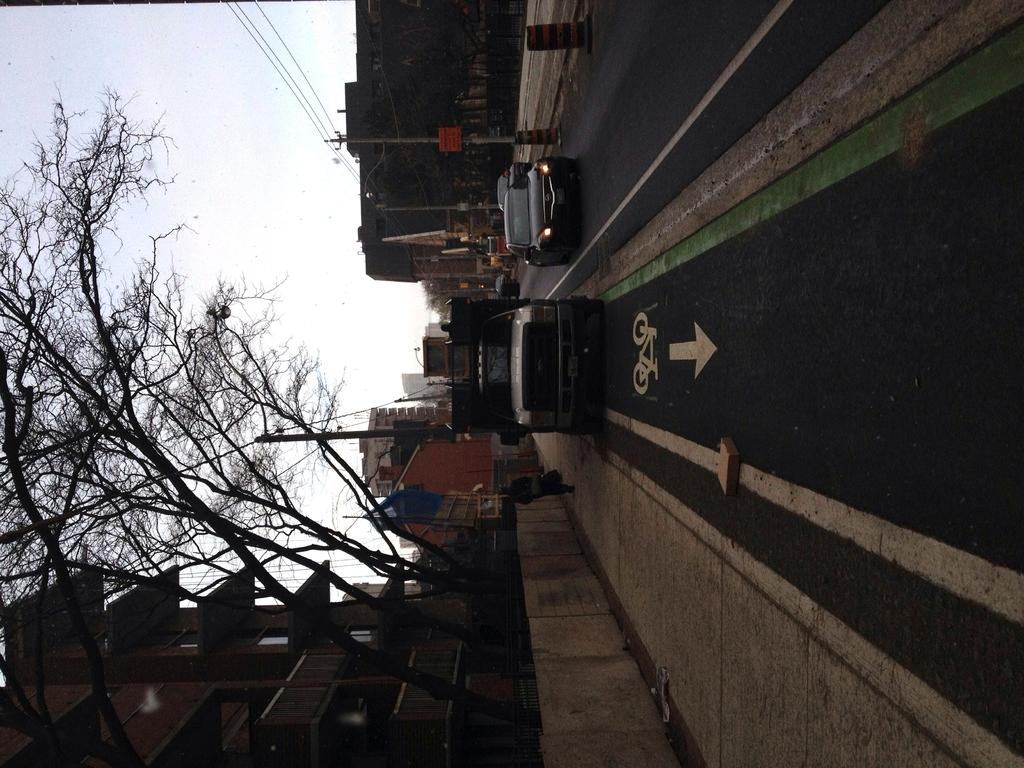What type of structures can be seen in the image? There are buildings in the image. What other natural elements are present in the image? There are trees in the image. What are the vertical structures in the image used for? There are poles in the image, which are likely used for support or signage. What are the flat, rectangular objects in the image? There are boards in the image, which could be signs or advertisements. What type of transportation is visible in the image? There are vehicles in the image, and they are on the road. Can you describe the person in the image? There is a person in the image, but their appearance or actions are not specified. What else can be seen in the image besides the mentioned elements? There are objects in the image, but their specific nature is not described. What can be seen in the background of the image? The sky is visible in the background of the image. How many roses can be seen growing on the poles in the image? There are no roses present on the poles in the image. What is the height of the person in the image compared to the objects around them? The height of the person in the image cannot be determined from the given facts. 